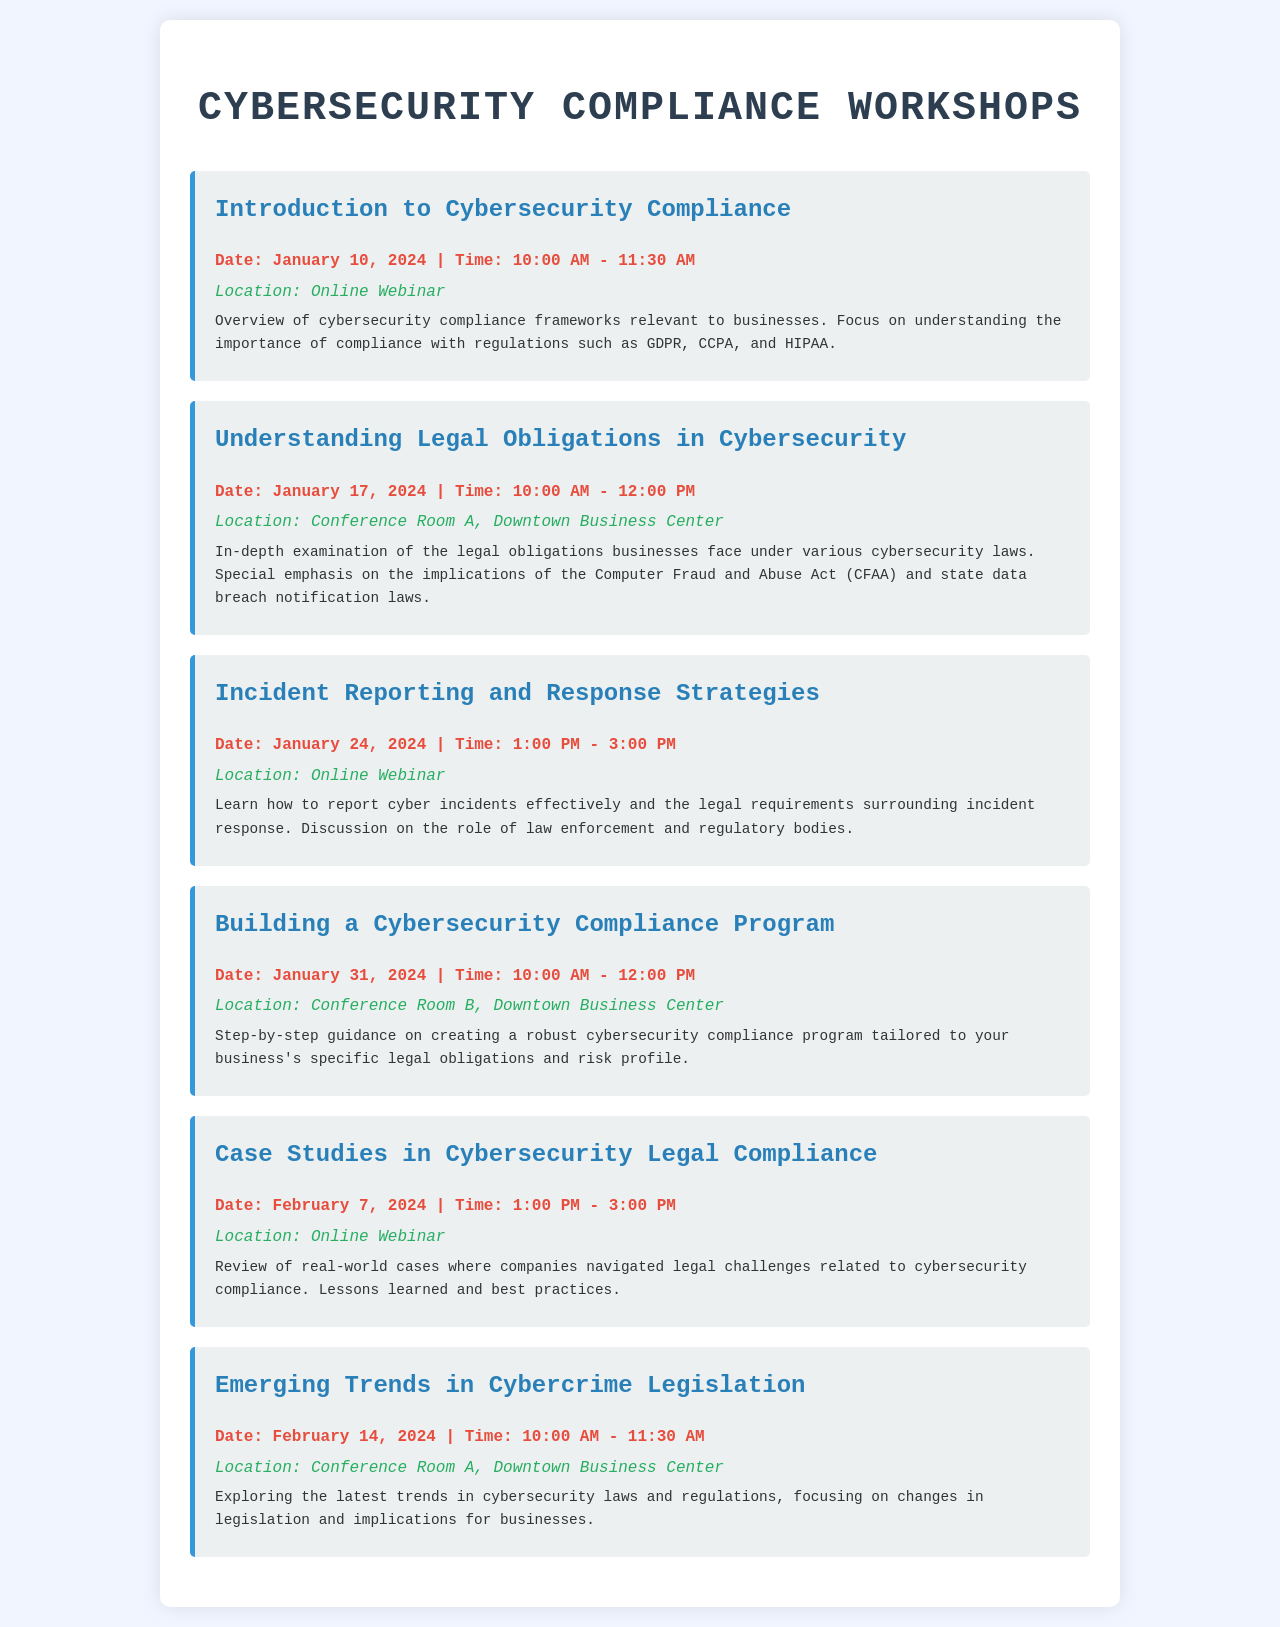What is the date of the workshop "Understanding Legal Obligations in Cybersecurity"? The date of the workshop "Understanding Legal Obligations in Cybersecurity" can be found under the corresponding workshop section.
Answer: January 17, 2024 What is the location of the workshop "Building a Cybersecurity Compliance Program"? The location is specified in the workshop details for "Building a Cybersecurity Compliance Program".
Answer: Conference Room B, Downtown Business Center What time does the workshop "Incident Reporting and Response Strategies" start? The start time is indicated in the date-time section for the workshop "Incident Reporting and Response Strategies".
Answer: 1:00 PM How many workshops are scheduled in total? The total number of workshops is determined by counting the workshop sections in the document.
Answer: Six What is the main focus of the workshop "Case Studies in Cybersecurity Legal Compliance"? The focus is described in the workshop's description section.
Answer: Review of real-world cases Which workshop addresses the Computer Fraud and Abuse Act? The workshop addressing the Computer Fraud and Abuse Act is specified in the title of that particular workshop.
Answer: Understanding Legal Obligations in Cybersecurity Which workshop format is held online? The online format is indicated for specific workshops in their location section.
Answer: Introduction to Cybersecurity Compliance, Incident Reporting and Response Strategies, Case Studies in Cybersecurity Legal Compliance 